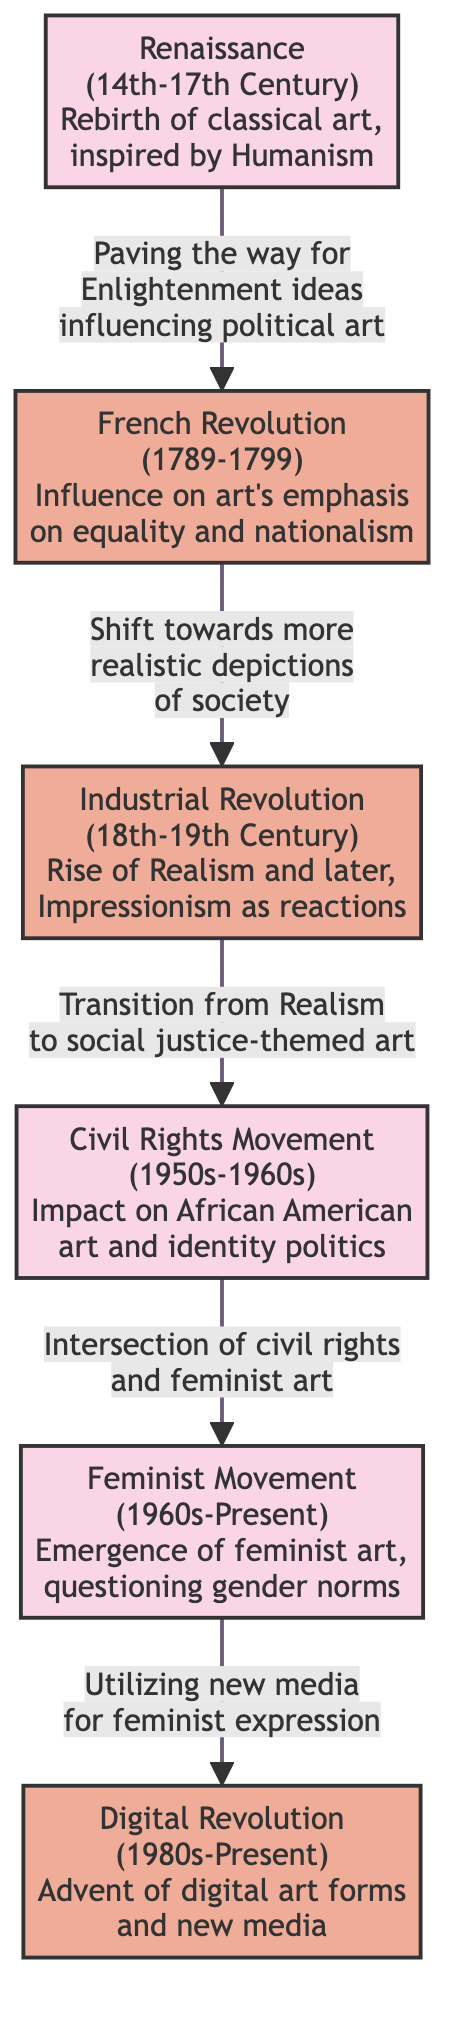What historical period does the Renaissance refer to? The diagram indicates that the Renaissance spans from the 14th to the 17th Century. This information can be retrieved directly from the description attached to the Renaissance node in the diagram.
Answer: 14th-17th Century Which movement had an influence on art's emphasis on equality and nationalism? The diagram links the French Revolution to the theme of equality and nationalism, showing its impact on artistic expression during that period. This relationship is clearly indicated in the connection and description provided in the diagram.
Answer: French Revolution What art movement emerged as a reaction to the Industrial Revolution? The flow from the Industrial Revolution to the Civil Rights Movement indicates that the transition led to social justice-themed art, particularly emphasizing shifts in the depictions of society. Thus, the art movement in focus is Realism, which was succeeded by related movements.
Answer: Realism How many major movements are represented in the diagram? By counting the individual nodes related to social movements and revolutions in the diagram, there are a total of six: Renaissance, French Revolution, Industrial Revolution, Civil Rights Movement, Feminist Movement, and Digital Revolution.
Answer: 6 What type of art does the Feminist Movement question? According to the description linked with the Feminist Movement node, it specifically addresses questioning gender norms in art, thus focusing on the feminist perspective in relation to traditional art practices.
Answer: Gender norms What is the connection between the Civil Rights Movement and the Feminist Movement? The diagram illustrates that the Civil Rights Movement influenced the intersection of civil rights and feminist art, implying a shared concern for identity and representation in the art world. This relationship shows a connection between the two movements through their shared thematic focus.
Answer: Intersection of civil rights and feminist art What kind of art forms emerged from the Digital Revolution? The description associated with the Digital Revolution node states it led to the advent of digital art forms and new media, indicating a shift towards modern artistic practices that utilize technology.
Answer: Digital art forms Which movement utilized new media for feminist expression? The diagram clearly states that the Feminist Movement is noted for utilizing new media as part of its expression, highlighting the integration of technology into feminist art practices.
Answer: Feminist Movement 